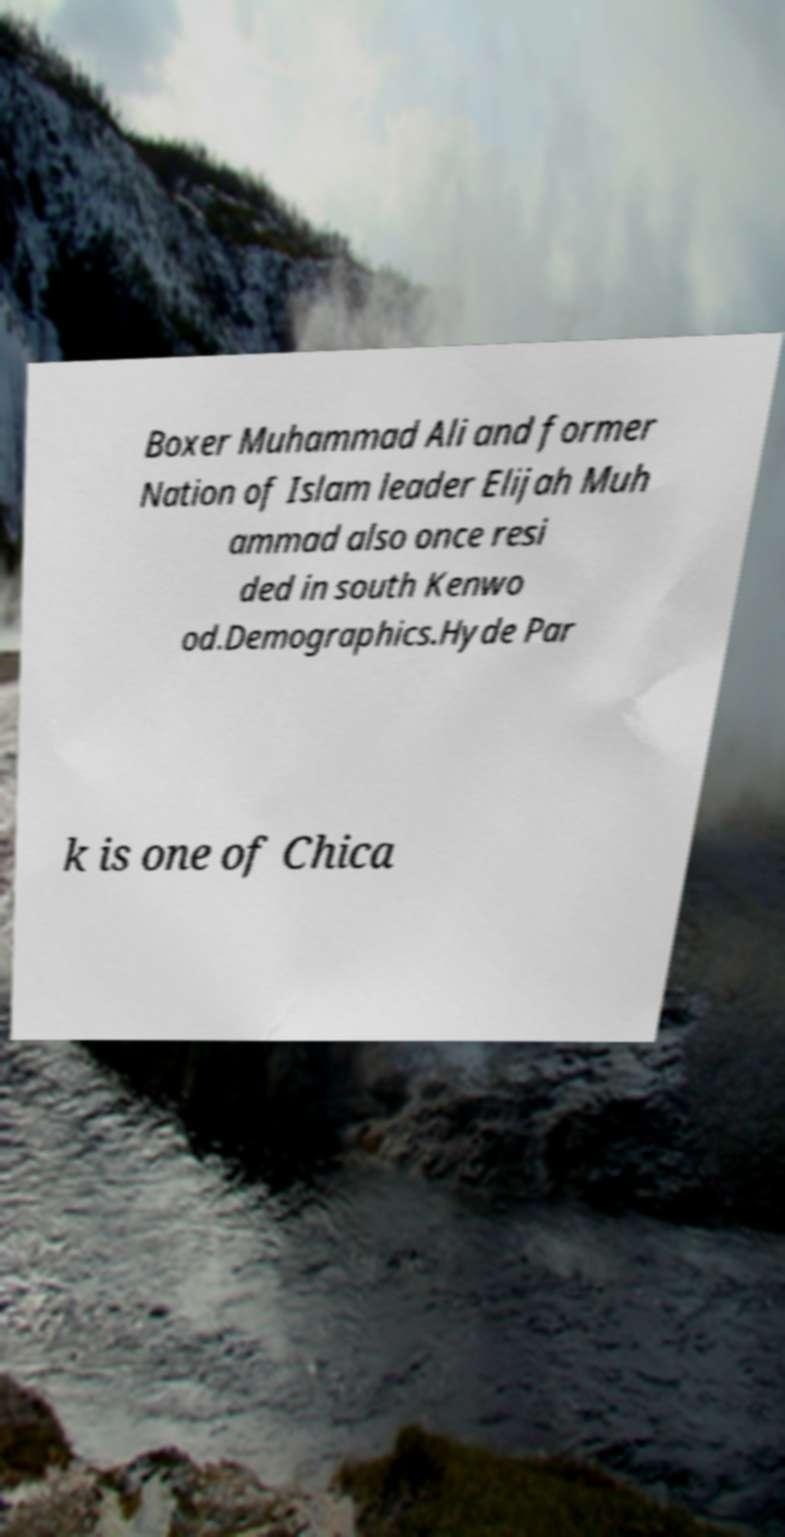For documentation purposes, I need the text within this image transcribed. Could you provide that? Boxer Muhammad Ali and former Nation of Islam leader Elijah Muh ammad also once resi ded in south Kenwo od.Demographics.Hyde Par k is one of Chica 